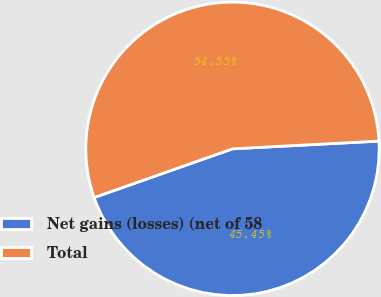Convert chart. <chart><loc_0><loc_0><loc_500><loc_500><pie_chart><fcel>Net gains (losses) (net of 58<fcel>Total<nl><fcel>45.45%<fcel>54.55%<nl></chart> 